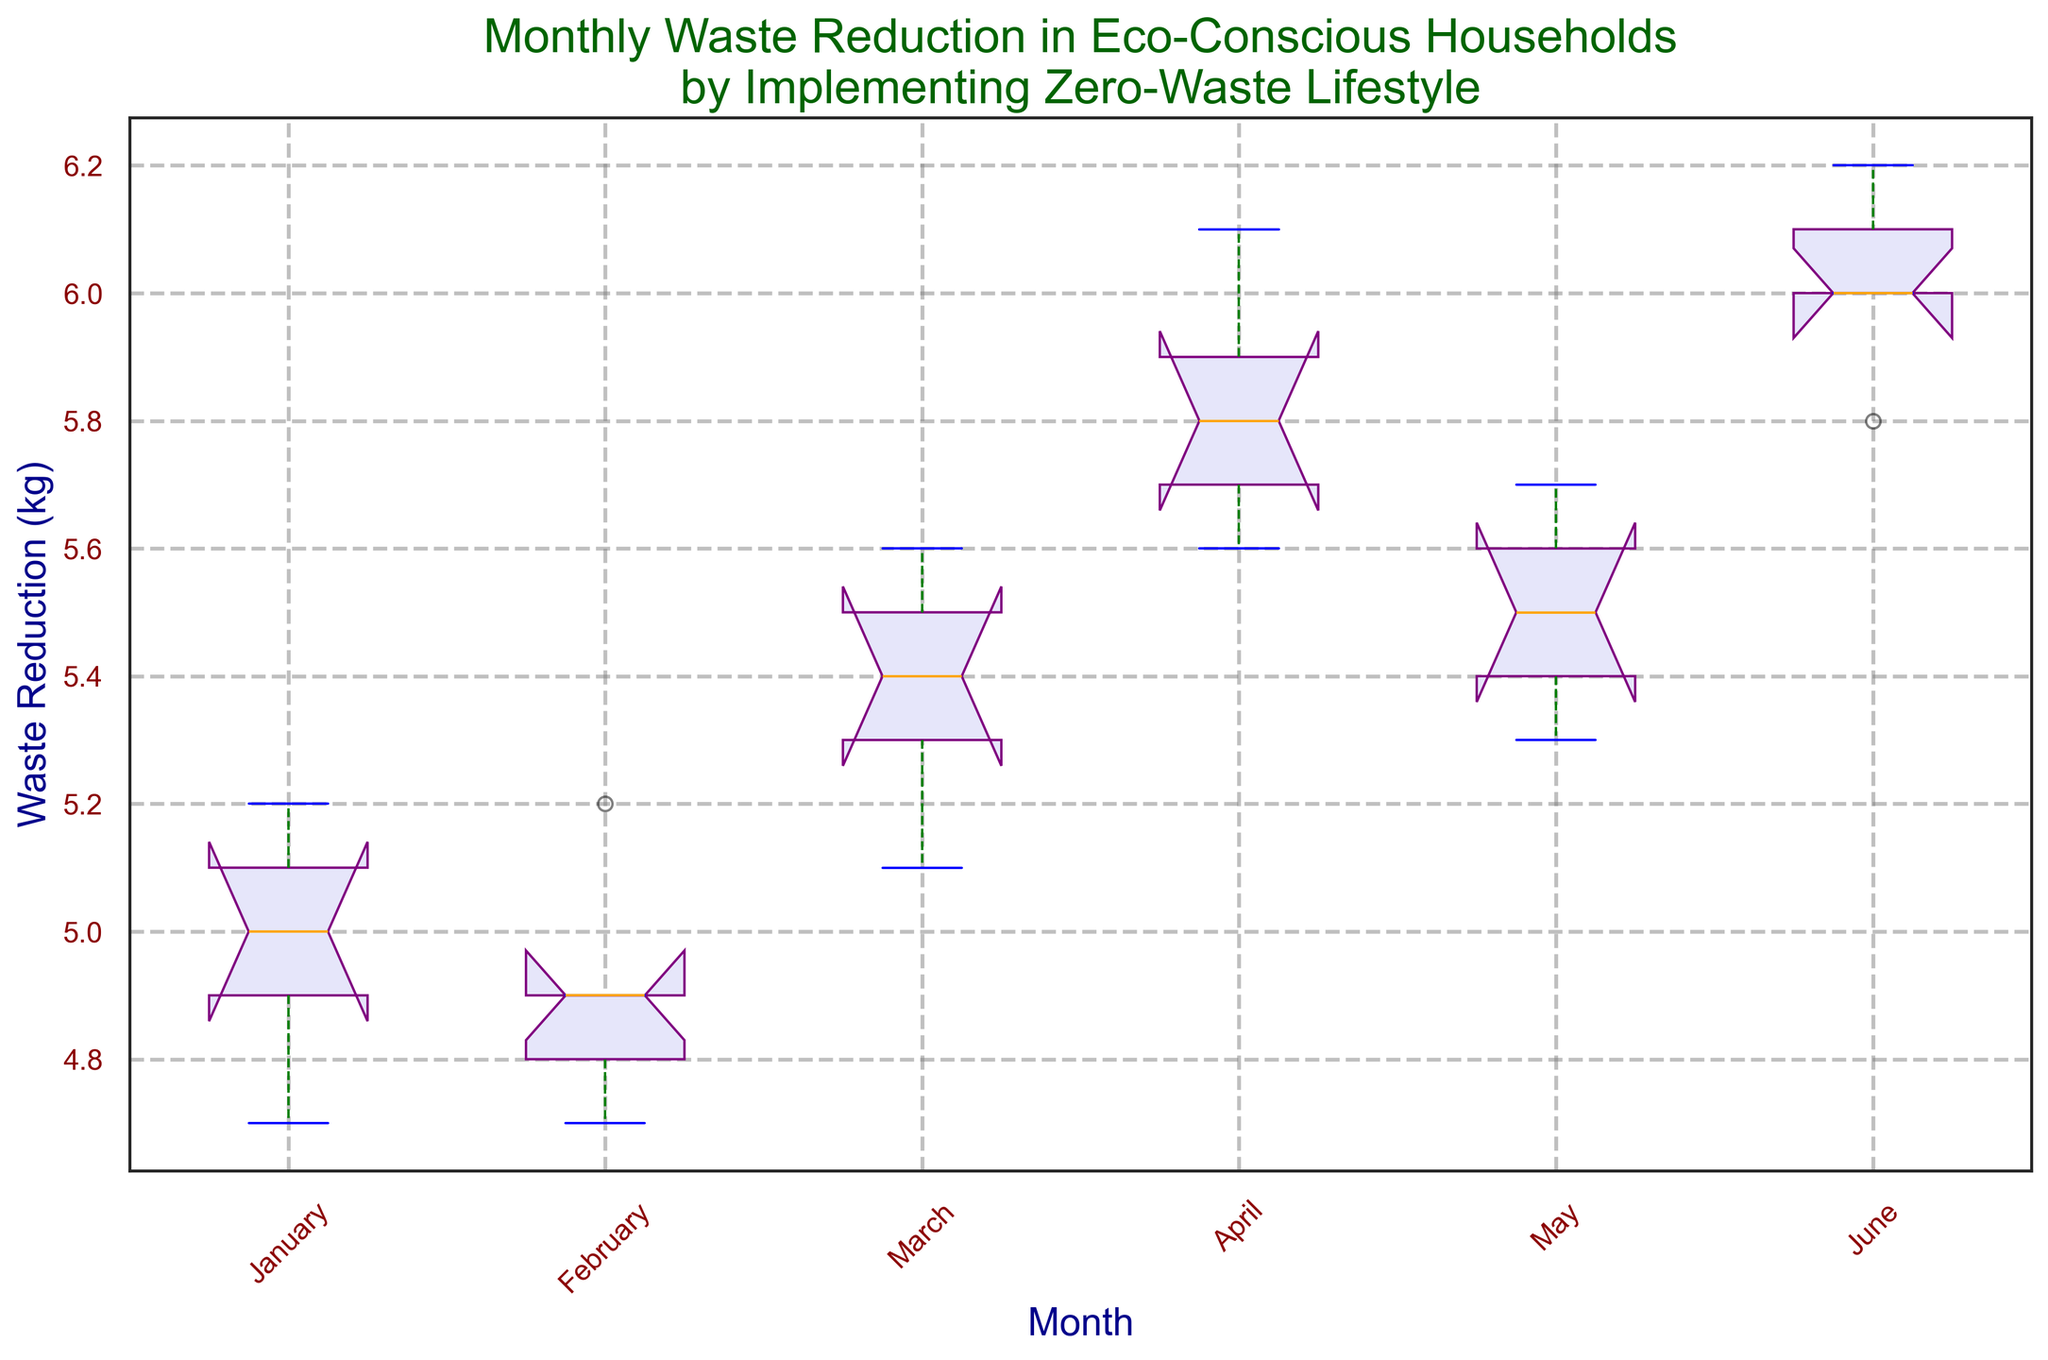What is the median waste reduction in March? To find the median waste reduction in March, look for the orange line within the box corresponding to March on the box plot.
Answer: 5.4 kg Which month has the highest median waste reduction? To determine the month with the highest median waste reduction, compare the height of the orange lines (medians) across all months. The month with the highest median will have the highest orange line.
Answer: June In which month is the range between the lower and upper quartiles the smallest? The range between the lower and upper quartiles is represented by the length of the box for each month. Identify the month with the shortest box to determine the smallest range.
Answer: January How does the median waste reduction in April compare to that in February? Compare the height of the orange lines (medians) for April and February. If April's orange line is higher, its median is higher, and vice versa.
Answer: April’s median is higher What is the interquartile range (IQR) for waste reduction in May? The IQR is the range between the 25th percentile (bottom of the box) and the 75th percentile (top of the box) for a month. Measure this vertical distance for May.
Answer: 0.4 kg Which month shows the highest variability in waste reduction? Variability is indicated by the length of the whiskers and potential outliers. Identify the month with the longest whiskers or numerous outliers.
Answer: June Are there any outliers in the waste reduction data? If so, in which months do they occur? Outliers are depicted as red circles outside the whiskers. Look for red circles for each month to identify where outliers occur, if any.
Answer: No outliers In which month do households have the most consistent waste reduction efforts? Consistency is reflected by a narrow range between the lower and upper quartiles and shorter whiskers. Identify the month with the smallest box and shortest whiskers.
Answer: January 